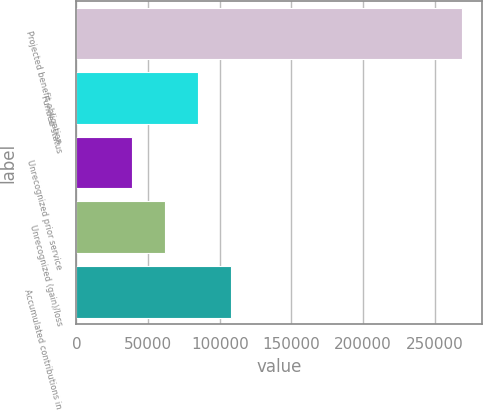Convert chart to OTSL. <chart><loc_0><loc_0><loc_500><loc_500><bar_chart><fcel>Projected benefit obligation<fcel>Funded status<fcel>Unrecognized prior service<fcel>Unrecognized (gain)/loss<fcel>Accumulated contributions in<nl><fcel>269438<fcel>84774<fcel>38608<fcel>61691<fcel>107857<nl></chart> 